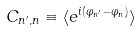Convert formula to latex. <formula><loc_0><loc_0><loc_500><loc_500>C _ { n ^ { \prime } , n } \equiv \langle e ^ { i \left ( \varphi _ { n ^ { \prime } } - \varphi _ { n } \right ) } \rangle</formula> 